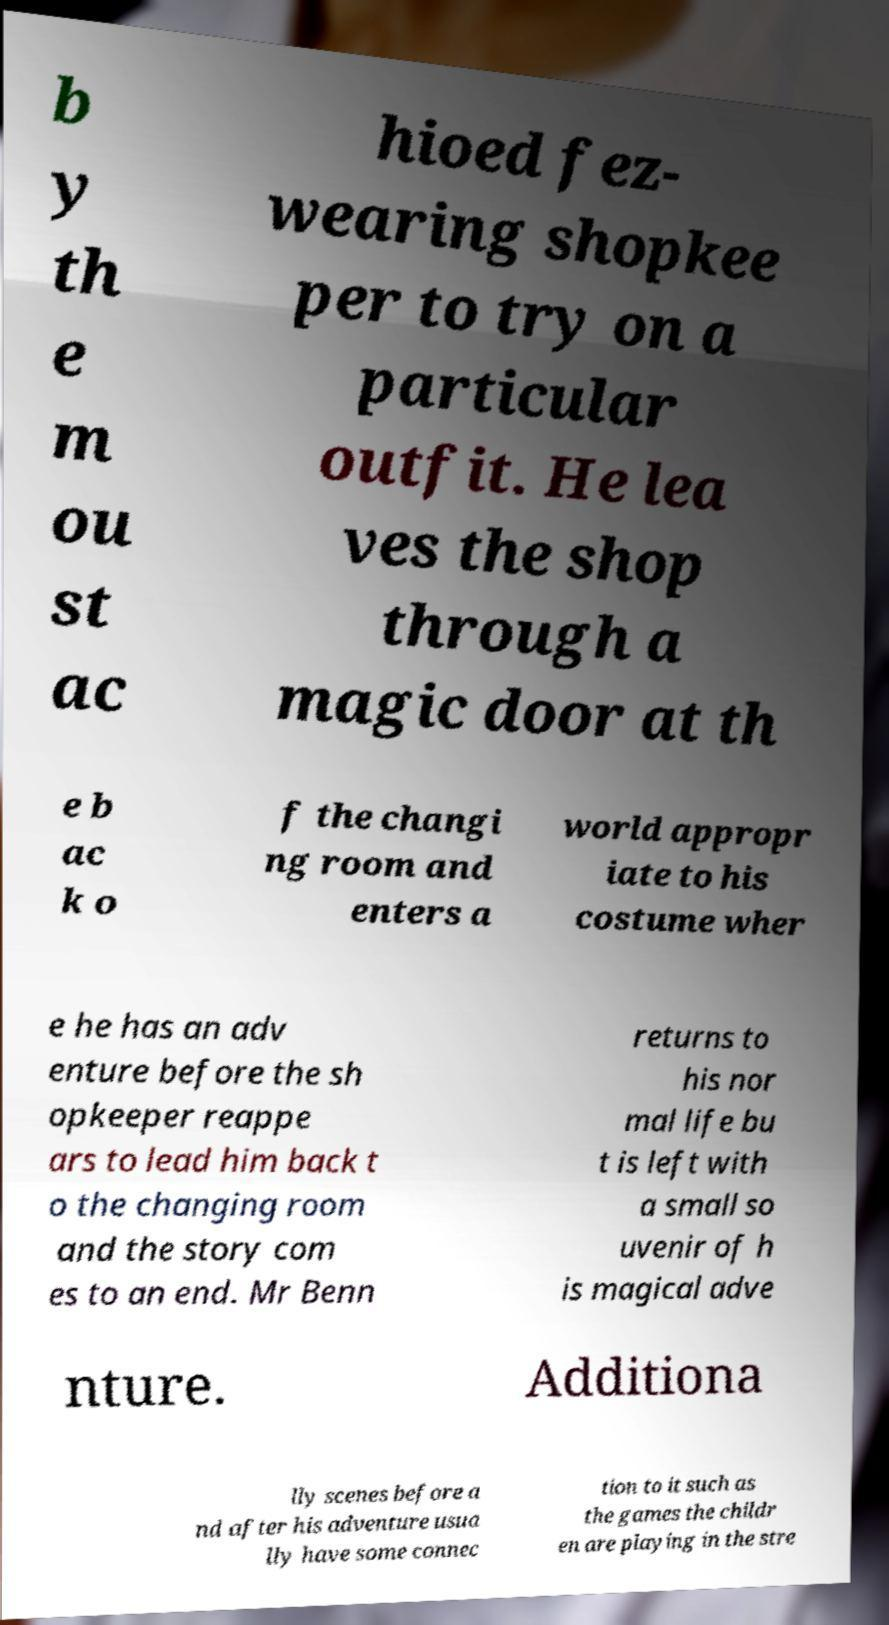What messages or text are displayed in this image? I need them in a readable, typed format. b y th e m ou st ac hioed fez- wearing shopkee per to try on a particular outfit. He lea ves the shop through a magic door at th e b ac k o f the changi ng room and enters a world appropr iate to his costume wher e he has an adv enture before the sh opkeeper reappe ars to lead him back t o the changing room and the story com es to an end. Mr Benn returns to his nor mal life bu t is left with a small so uvenir of h is magical adve nture. Additiona lly scenes before a nd after his adventure usua lly have some connec tion to it such as the games the childr en are playing in the stre 